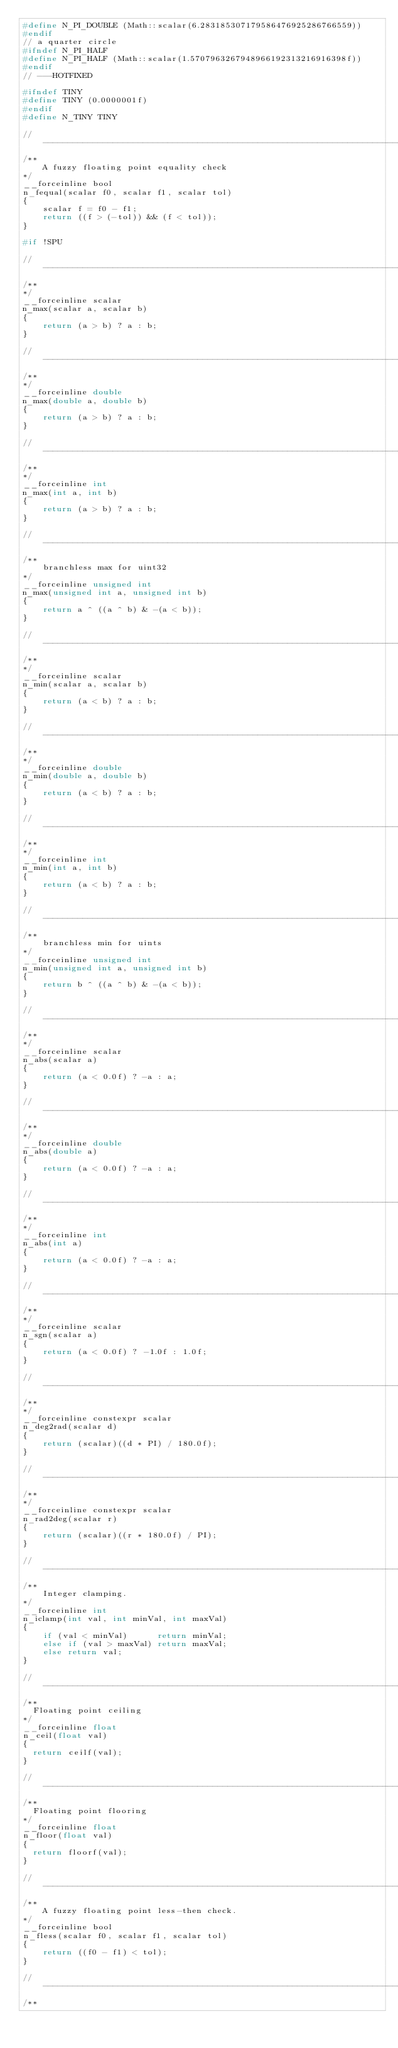<code> <loc_0><loc_0><loc_500><loc_500><_C_>#define N_PI_DOUBLE (Math::scalar(6.283185307179586476925286766559))
#endif
// a quarter circle
#ifndef N_PI_HALF
#define N_PI_HALF (Math::scalar(1.5707963267948966192313216916398f))
#endif
// ---HOTFIXED

#ifndef TINY
#define TINY (0.0000001f)
#endif
#define N_TINY TINY

//------------------------------------------------------------------------------
/**
    A fuzzy floating point equality check
*/
__forceinline bool
n_fequal(scalar f0, scalar f1, scalar tol)
{
    scalar f = f0 - f1;
    return ((f > (-tol)) && (f < tol));
}

#if !SPU

//------------------------------------------------------------------------------
/**
*/
__forceinline scalar
n_max(scalar a, scalar b)
{
    return (a > b) ? a : b;
}

//------------------------------------------------------------------------------
/**
*/
__forceinline double
n_max(double a, double b)
{
    return (a > b) ? a : b;
}

//------------------------------------------------------------------------------
/**
*/
__forceinline int
n_max(int a, int b)
{
    return (a > b) ? a : b;
}

//------------------------------------------------------------------------------
/**
    branchless max for uint32
*/
__forceinline unsigned int
n_max(unsigned int a, unsigned int b)
{
    return a ^ ((a ^ b) & -(a < b));
}

//------------------------------------------------------------------------------
/**
*/
__forceinline scalar
n_min(scalar a, scalar b)
{
    return (a < b) ? a : b;
}

//------------------------------------------------------------------------------
/**
*/
__forceinline double
n_min(double a, double b)
{
    return (a < b) ? a : b;
}

//------------------------------------------------------------------------------
/**
*/
__forceinline int
n_min(int a, int b)
{
    return (a < b) ? a : b;
}

//------------------------------------------------------------------------------
/**
    branchless min for uints
*/
__forceinline unsigned int
n_min(unsigned int a, unsigned int b)
{
    return b ^ ((a ^ b) & -(a < b));
}

//------------------------------------------------------------------------------
/**
*/
__forceinline scalar
n_abs(scalar a)
{
    return (a < 0.0f) ? -a : a;
}

//------------------------------------------------------------------------------
/**
*/
__forceinline double
n_abs(double a)
{
    return (a < 0.0f) ? -a : a;
}

//------------------------------------------------------------------------------
/**
*/
__forceinline int
n_abs(int a)
{
    return (a < 0.0f) ? -a : a;
}

//------------------------------------------------------------------------------
/**
*/
__forceinline scalar
n_sgn(scalar a)
{
    return (a < 0.0f) ? -1.0f : 1.0f;
}

//------------------------------------------------------------------------------
/**
*/
__forceinline constexpr scalar
n_deg2rad(scalar d)
{
    return (scalar)((d * PI) / 180.0f);
}

//------------------------------------------------------------------------------
/**
*/
__forceinline constexpr scalar
n_rad2deg(scalar r)
{
    return (scalar)((r * 180.0f) / PI);
}

//------------------------------------------------------------------------------
/**
    Integer clamping.
*/
__forceinline int
n_iclamp(int val, int minVal, int maxVal)
{
    if (val < minVal)      return minVal;
    else if (val > maxVal) return maxVal;
    else return val;
}

//------------------------------------------------------------------------------
/**
	Floating point ceiling
*/
__forceinline float
n_ceil(float val)
{
	return ceilf(val);
}

//------------------------------------------------------------------------------
/**
	Floating point flooring
*/
__forceinline float
n_floor(float val)
{
	return floorf(val);
}

//------------------------------------------------------------------------------
/**
    A fuzzy floating point less-then check.
*/
__forceinline bool
n_fless(scalar f0, scalar f1, scalar tol)
{
    return ((f0 - f1) < tol);
}

//------------------------------------------------------------------------------
/**</code> 